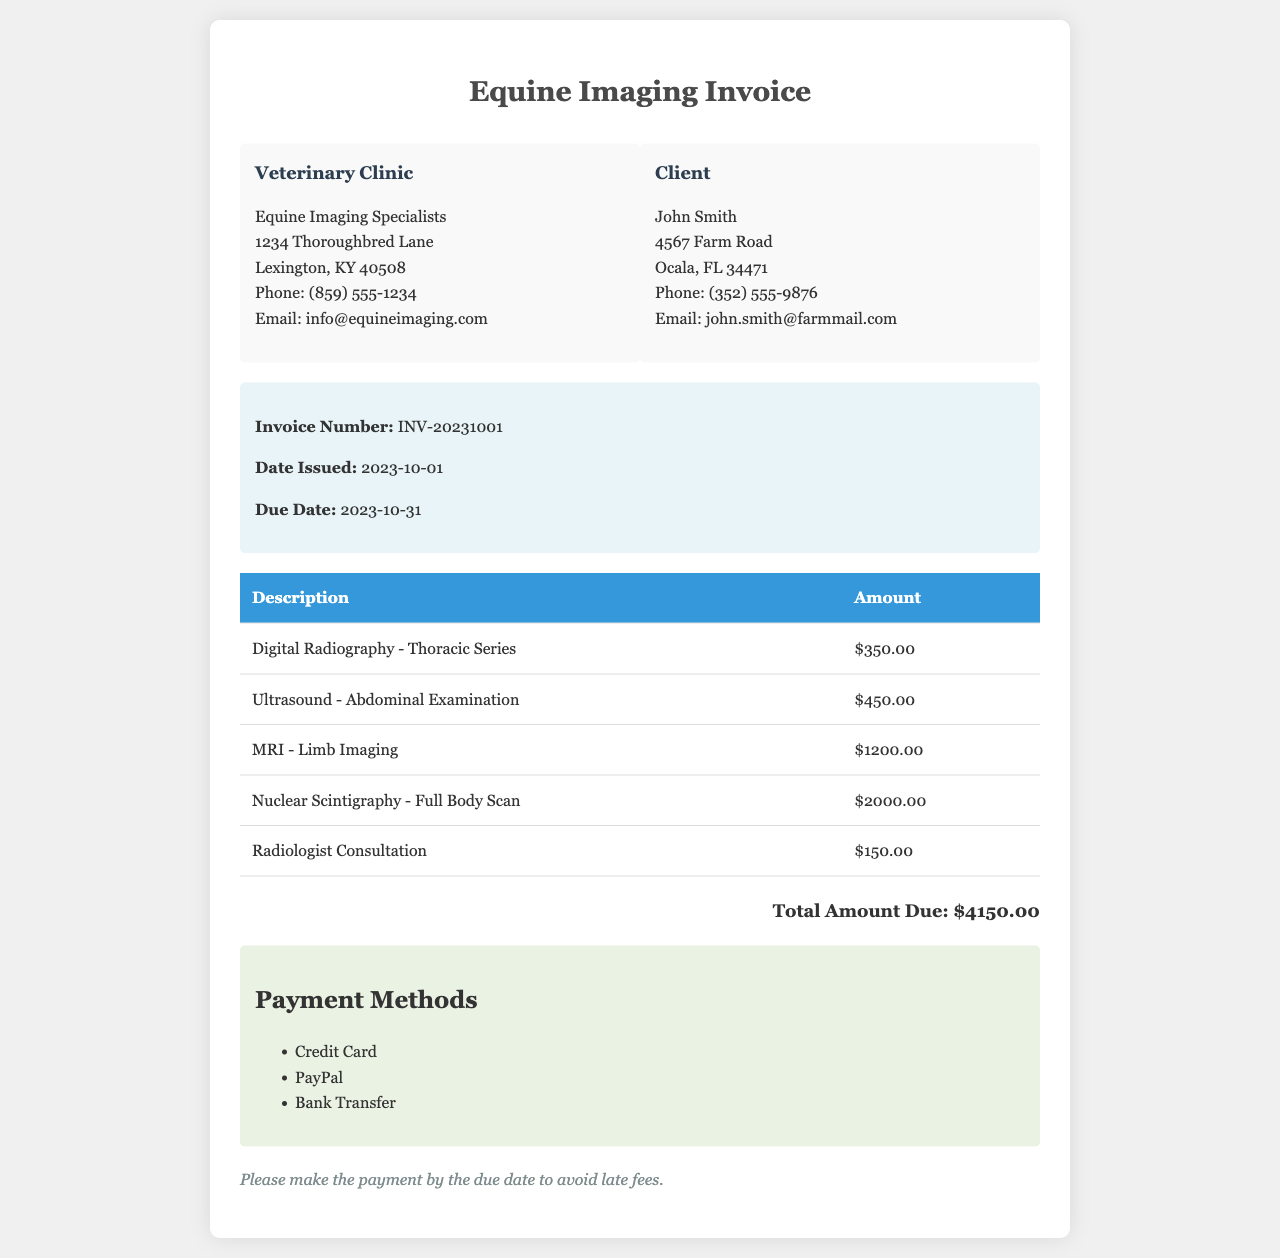What is the invoice number? The invoice number is prominently displayed in the invoice details section and is labeled as such.
Answer: INV-20231001 Who is the client? The client's name is clearly mentioned in the client information section of the invoice.
Answer: John Smith What is the total amount due? The total amount due is stated at the bottom of the invoice, summarizing the costs from all charges.
Answer: $4150.00 What imaging technique has the highest charge? The imaging techniques are listed in the table, and each charge is provided. The highest charge can be identified in the amounts listed.
Answer: Nuclear Scintigraphy - Full Body Scan When is the due date for payment? The due date is indicated in the invoice details section, which is explicitly mentioned.
Answer: 2023-10-31 What is the charge for Radiologist Consultation? The charge for this service is detailed in the invoice table where all charges are listed.
Answer: $150.00 How many payment methods are listed? The payment methods section outlines the options for paying the invoice. The number of listed methods provides the answer.
Answer: 3 What is the date the invoice was issued? The date issued is clearly written in the invoice details section under the appropriate label.
Answer: 2023-10-01 